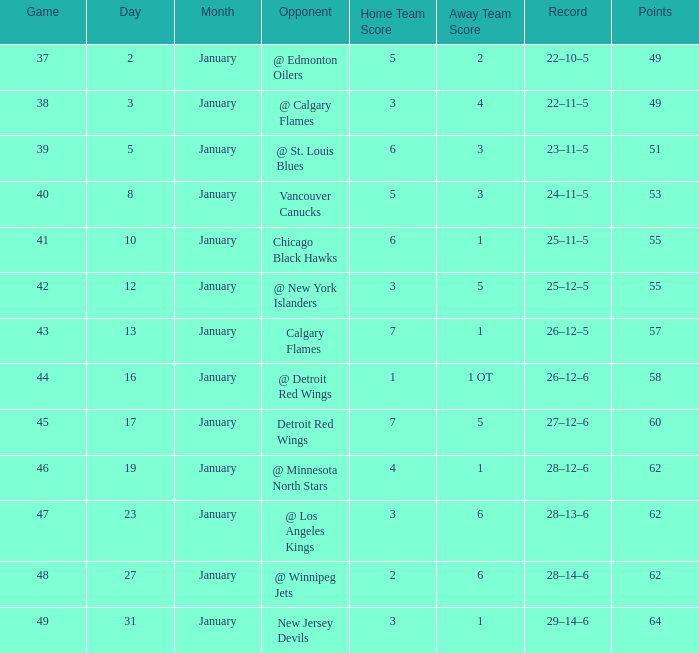Which Points have a Score of 4–1? 62.0. 